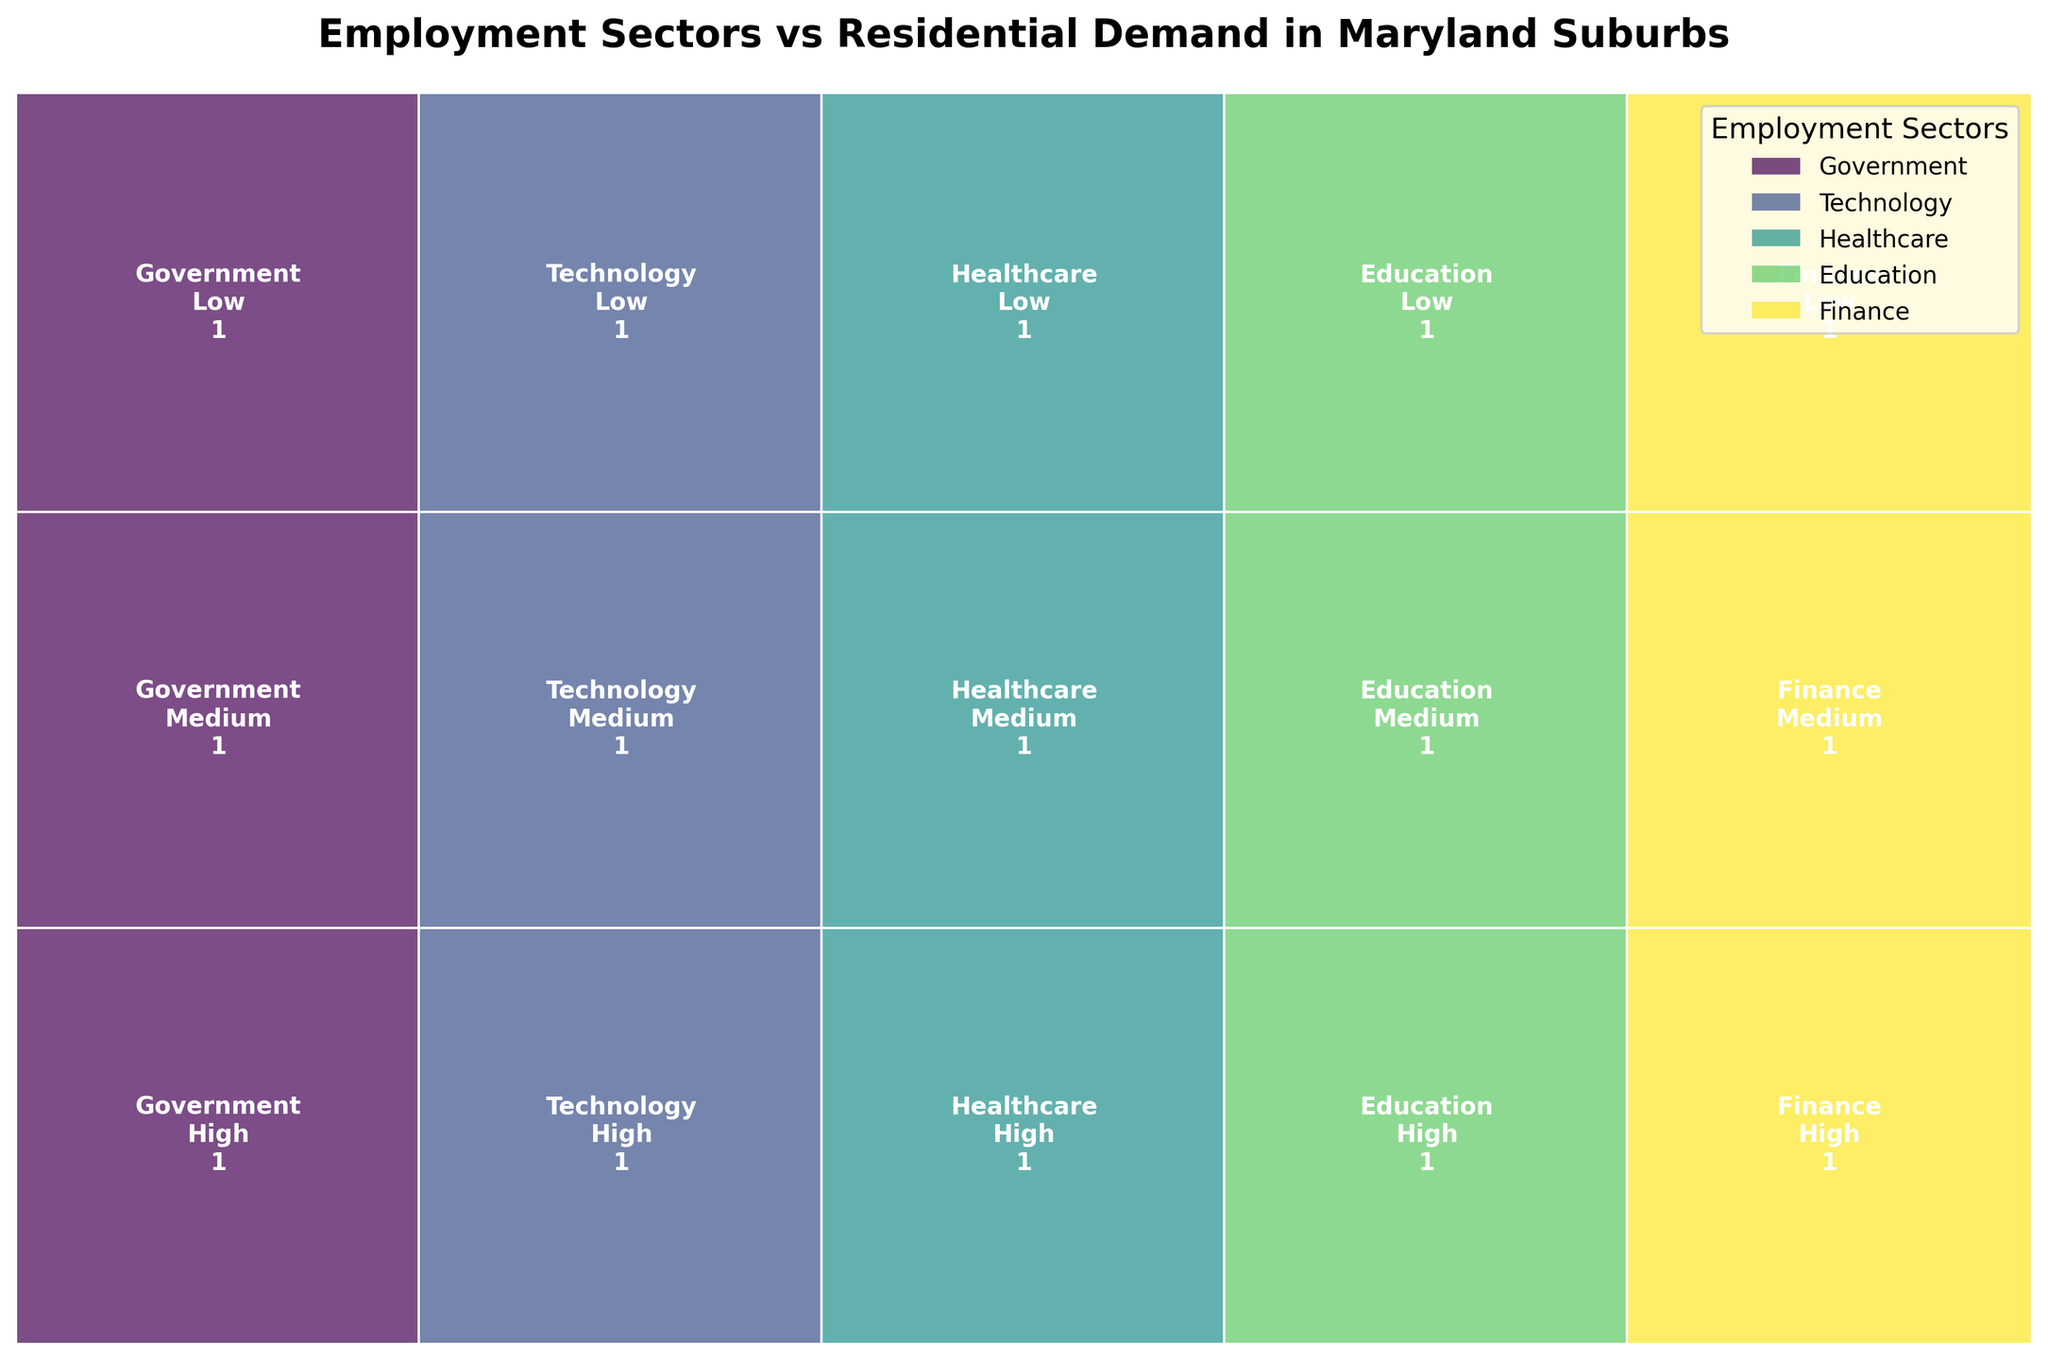Which employment sector has the highest residential demand in Bethesda? The figure shows the demand distribution for each employment sector in various suburbs. Look for Bethesda under "Government" and notice the associated demand level.
Answer: High How many suburbs have a medium residential demand for the Technology sector? Identify the "Technology" sector and count the rectangles labeled "Medium" within that sector.
Answer: 1 Is there any employment sector that has a low residential demand in more than one suburb? Check all sectors for rectangles labeled "Low" and count how many have more than one such rectangle.
Answer: No Which suburb has a high residential demand in the Healthcare sector? Locate the "Healthcare" sector and find the rectangle labeled "High." Identify the suburb listed in the rectangle.
Answer: Towson How does the medium residential demand for the Finance sector compare with that of the Education sector? Identify and compare the rectangles labeled "Medium" under the "Finance" and "Education" sectors.
Answer: Same What is the total number of suburbs with either high or medium residential demand in the Education sector? Find and count the rectangles labeled "High" and "Medium" in the "Education" sector.
Answer: 2 Which sector has the least number of suburbs with high residential demand? Compare the number of "High" demand rectangles across each sector. Identify the sector with the fewest.
Answer: Education Are there more suburbs with low residential demand in the "Government" sector or in the "Finance" sector? Identify and count the rectangles labeled "Low" in the "Government" and "Finance" sectors. Compare their counts.
Answer: Government How many sectors have at least one suburb with high residential demand? Count the unique sectors that have at least one "High" demand rectangle.
Answer: 5 